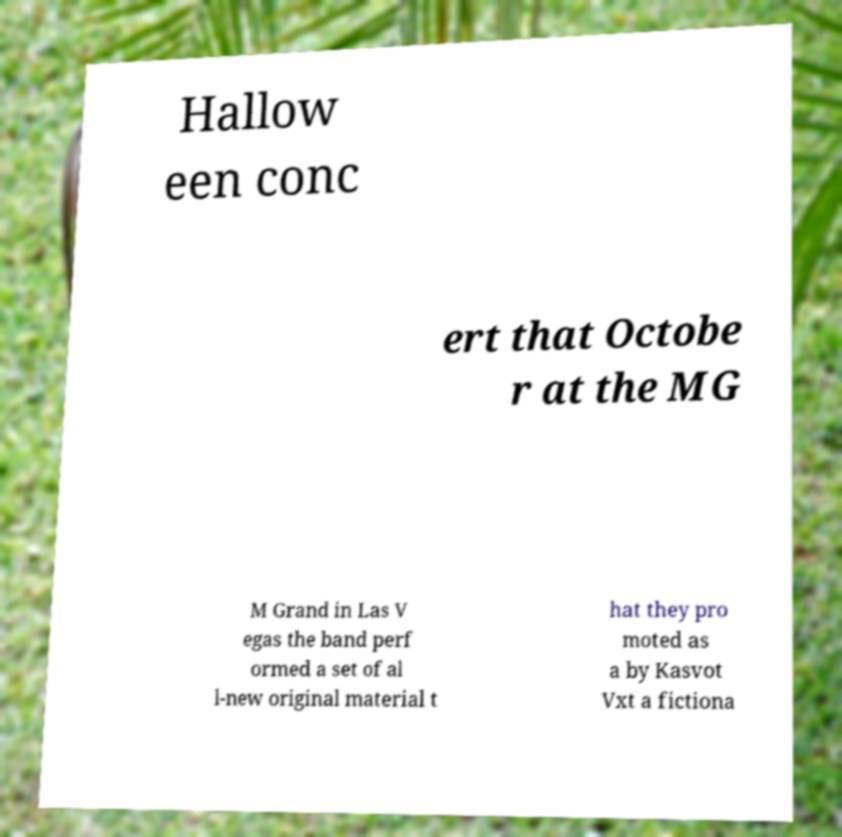Can you read and provide the text displayed in the image?This photo seems to have some interesting text. Can you extract and type it out for me? Hallow een conc ert that Octobe r at the MG M Grand in Las V egas the band perf ormed a set of al l-new original material t hat they pro moted as a by Kasvot Vxt a fictiona 